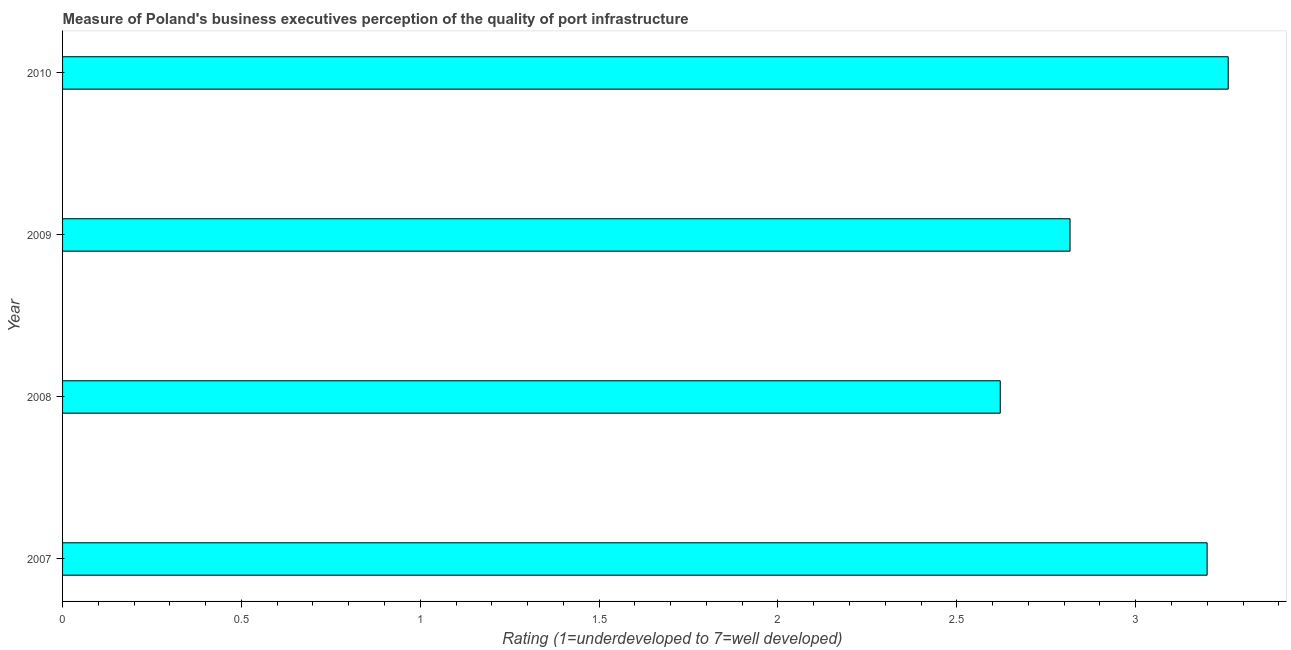Does the graph contain any zero values?
Provide a succinct answer. No. What is the title of the graph?
Offer a terse response. Measure of Poland's business executives perception of the quality of port infrastructure. What is the label or title of the X-axis?
Give a very brief answer. Rating (1=underdeveloped to 7=well developed) . What is the label or title of the Y-axis?
Provide a succinct answer. Year. What is the rating measuring quality of port infrastructure in 2008?
Your answer should be compact. 2.62. Across all years, what is the maximum rating measuring quality of port infrastructure?
Provide a short and direct response. 3.26. Across all years, what is the minimum rating measuring quality of port infrastructure?
Your answer should be very brief. 2.62. In which year was the rating measuring quality of port infrastructure maximum?
Your answer should be very brief. 2010. What is the sum of the rating measuring quality of port infrastructure?
Provide a short and direct response. 11.9. What is the difference between the rating measuring quality of port infrastructure in 2009 and 2010?
Ensure brevity in your answer.  -0.44. What is the average rating measuring quality of port infrastructure per year?
Offer a terse response. 2.97. What is the median rating measuring quality of port infrastructure?
Offer a very short reply. 3.01. In how many years, is the rating measuring quality of port infrastructure greater than 2.9 ?
Keep it short and to the point. 2. What is the ratio of the rating measuring quality of port infrastructure in 2009 to that in 2010?
Ensure brevity in your answer.  0.86. What is the difference between the highest and the second highest rating measuring quality of port infrastructure?
Your answer should be very brief. 0.06. What is the difference between the highest and the lowest rating measuring quality of port infrastructure?
Your answer should be very brief. 0.64. In how many years, is the rating measuring quality of port infrastructure greater than the average rating measuring quality of port infrastructure taken over all years?
Offer a very short reply. 2. Are all the bars in the graph horizontal?
Offer a terse response. Yes. Are the values on the major ticks of X-axis written in scientific E-notation?
Provide a succinct answer. No. What is the Rating (1=underdeveloped to 7=well developed)  in 2007?
Make the answer very short. 3.2. What is the Rating (1=underdeveloped to 7=well developed)  of 2008?
Provide a short and direct response. 2.62. What is the Rating (1=underdeveloped to 7=well developed)  in 2009?
Provide a succinct answer. 2.82. What is the Rating (1=underdeveloped to 7=well developed)  in 2010?
Provide a succinct answer. 3.26. What is the difference between the Rating (1=underdeveloped to 7=well developed)  in 2007 and 2008?
Offer a very short reply. 0.58. What is the difference between the Rating (1=underdeveloped to 7=well developed)  in 2007 and 2009?
Make the answer very short. 0.38. What is the difference between the Rating (1=underdeveloped to 7=well developed)  in 2007 and 2010?
Provide a succinct answer. -0.06. What is the difference between the Rating (1=underdeveloped to 7=well developed)  in 2008 and 2009?
Your answer should be compact. -0.2. What is the difference between the Rating (1=underdeveloped to 7=well developed)  in 2008 and 2010?
Your response must be concise. -0.64. What is the difference between the Rating (1=underdeveloped to 7=well developed)  in 2009 and 2010?
Ensure brevity in your answer.  -0.44. What is the ratio of the Rating (1=underdeveloped to 7=well developed)  in 2007 to that in 2008?
Give a very brief answer. 1.22. What is the ratio of the Rating (1=underdeveloped to 7=well developed)  in 2007 to that in 2009?
Provide a short and direct response. 1.14. What is the ratio of the Rating (1=underdeveloped to 7=well developed)  in 2007 to that in 2010?
Provide a short and direct response. 0.98. What is the ratio of the Rating (1=underdeveloped to 7=well developed)  in 2008 to that in 2010?
Your answer should be compact. 0.8. What is the ratio of the Rating (1=underdeveloped to 7=well developed)  in 2009 to that in 2010?
Offer a terse response. 0.86. 